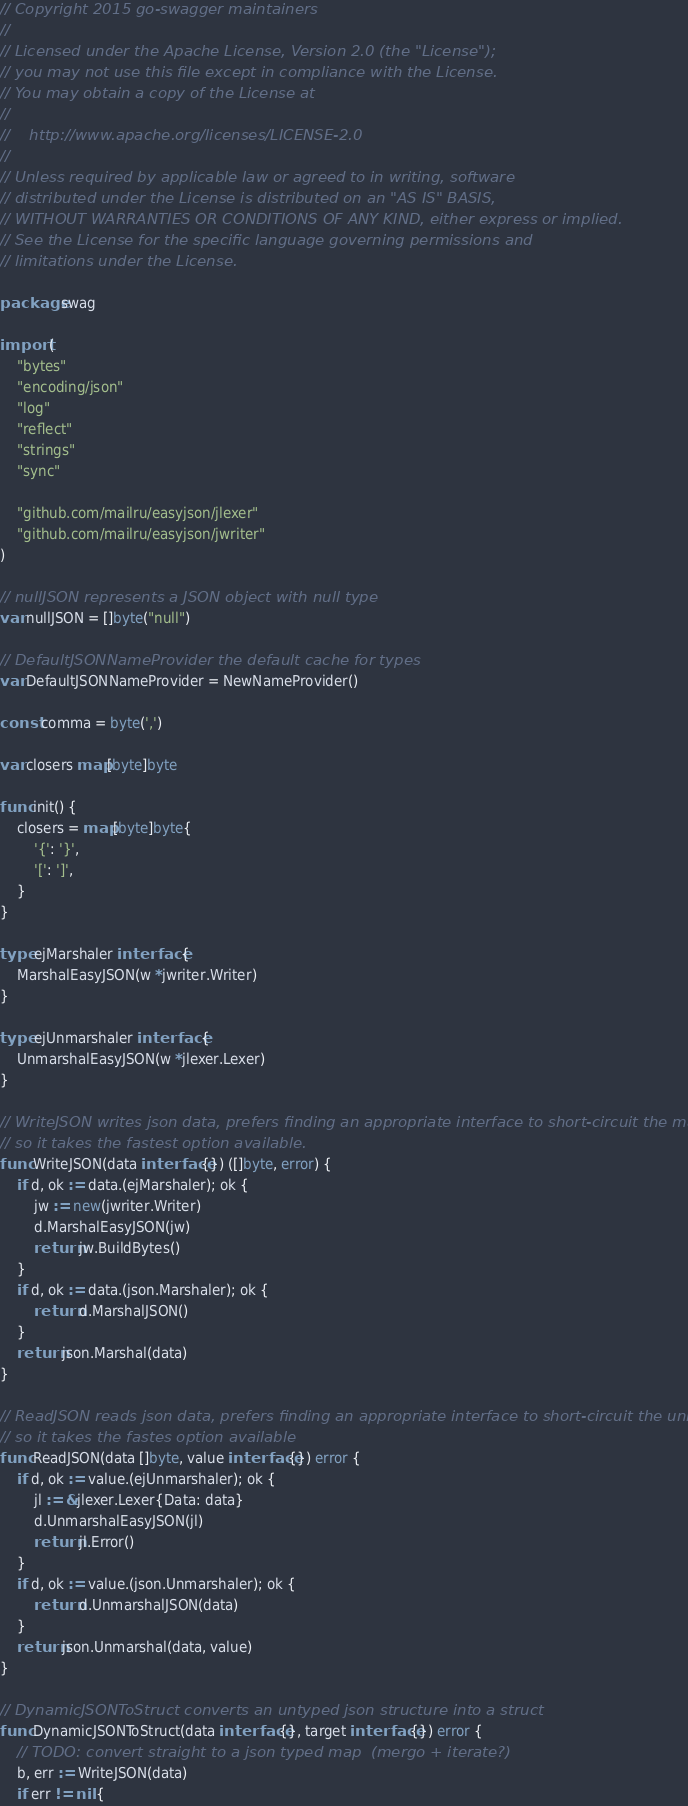<code> <loc_0><loc_0><loc_500><loc_500><_Go_>// Copyright 2015 go-swagger maintainers
//
// Licensed under the Apache License, Version 2.0 (the "License");
// you may not use this file except in compliance with the License.
// You may obtain a copy of the License at
//
//    http://www.apache.org/licenses/LICENSE-2.0
//
// Unless required by applicable law or agreed to in writing, software
// distributed under the License is distributed on an "AS IS" BASIS,
// WITHOUT WARRANTIES OR CONDITIONS OF ANY KIND, either express or implied.
// See the License for the specific language governing permissions and
// limitations under the License.

package swag

import (
	"bytes"
	"encoding/json"
	"log"
	"reflect"
	"strings"
	"sync"

	"github.com/mailru/easyjson/jlexer"
	"github.com/mailru/easyjson/jwriter"
)

// nullJSON represents a JSON object with null type
var nullJSON = []byte("null")

// DefaultJSONNameProvider the default cache for types
var DefaultJSONNameProvider = NewNameProvider()

const comma = byte(',')

var closers map[byte]byte

func init() {
	closers = map[byte]byte{
		'{': '}',
		'[': ']',
	}
}

type ejMarshaler interface {
	MarshalEasyJSON(w *jwriter.Writer)
}

type ejUnmarshaler interface {
	UnmarshalEasyJSON(w *jlexer.Lexer)
}

// WriteJSON writes json data, prefers finding an appropriate interface to short-circuit the marshaller
// so it takes the fastest option available.
func WriteJSON(data interface{}) ([]byte, error) {
	if d, ok := data.(ejMarshaler); ok {
		jw := new(jwriter.Writer)
		d.MarshalEasyJSON(jw)
		return jw.BuildBytes()
	}
	if d, ok := data.(json.Marshaler); ok {
		return d.MarshalJSON()
	}
	return json.Marshal(data)
}

// ReadJSON reads json data, prefers finding an appropriate interface to short-circuit the unmarshaller
// so it takes the fastes option available
func ReadJSON(data []byte, value interface{}) error {
	if d, ok := value.(ejUnmarshaler); ok {
		jl := &jlexer.Lexer{Data: data}
		d.UnmarshalEasyJSON(jl)
		return jl.Error()
	}
	if d, ok := value.(json.Unmarshaler); ok {
		return d.UnmarshalJSON(data)
	}
	return json.Unmarshal(data, value)
}

// DynamicJSONToStruct converts an untyped json structure into a struct
func DynamicJSONToStruct(data interface{}, target interface{}) error {
	// TODO: convert straight to a json typed map  (mergo + iterate?)
	b, err := WriteJSON(data)
	if err != nil {</code> 